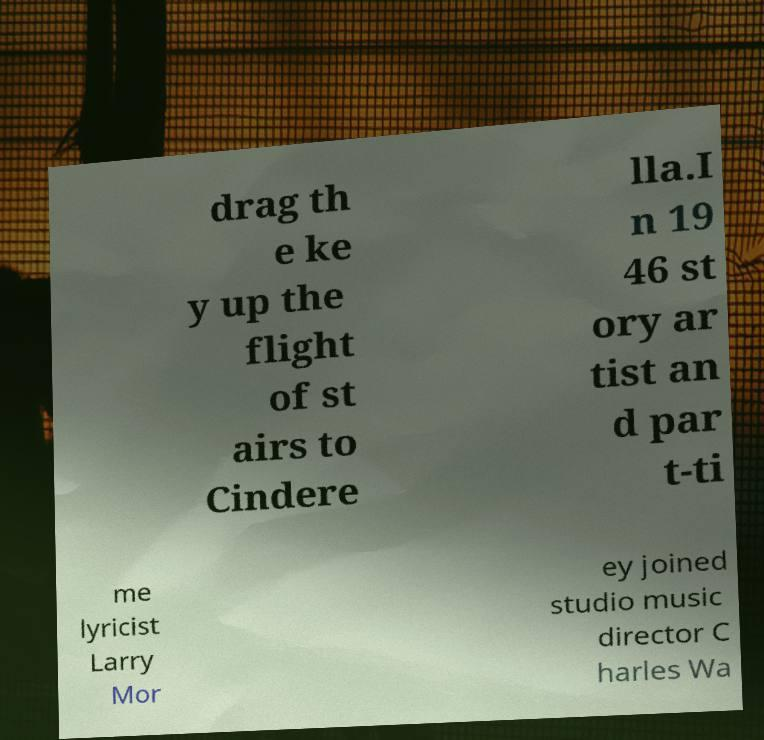Can you read and provide the text displayed in the image?This photo seems to have some interesting text. Can you extract and type it out for me? drag th e ke y up the flight of st airs to Cindere lla.I n 19 46 st ory ar tist an d par t-ti me lyricist Larry Mor ey joined studio music director C harles Wa 